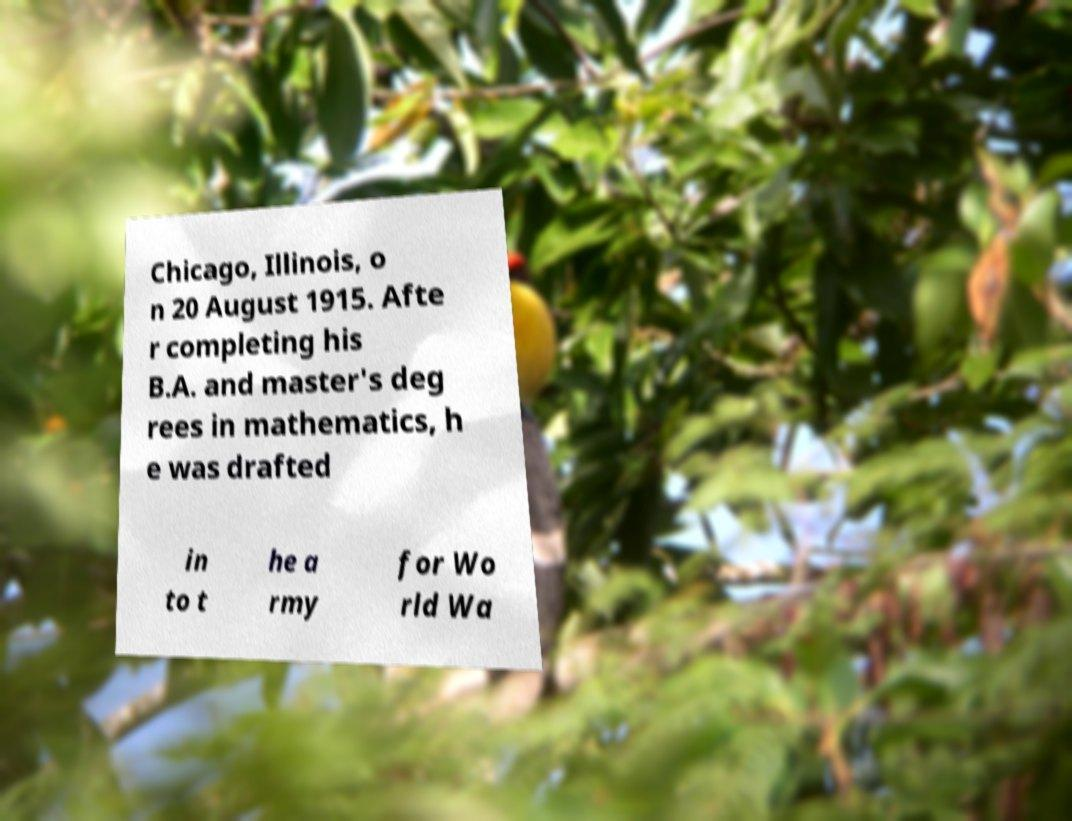Can you accurately transcribe the text from the provided image for me? Chicago, Illinois, o n 20 August 1915. Afte r completing his B.A. and master's deg rees in mathematics, h e was drafted in to t he a rmy for Wo rld Wa 